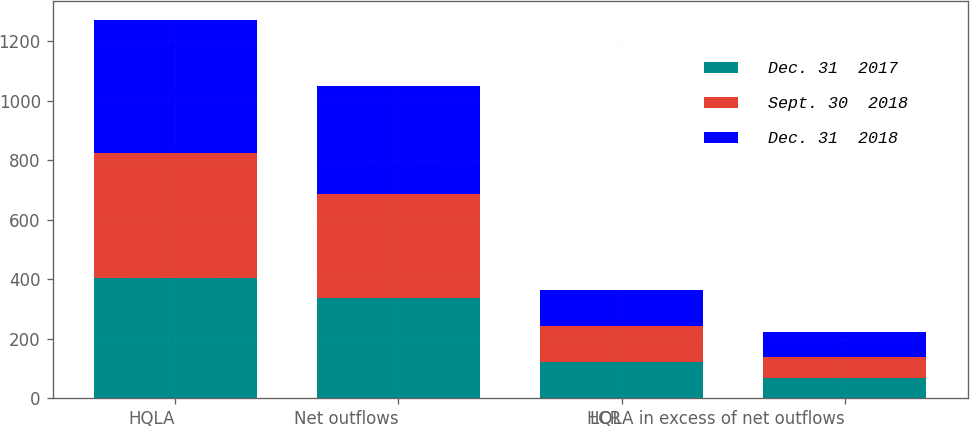Convert chart to OTSL. <chart><loc_0><loc_0><loc_500><loc_500><stacked_bar_chart><ecel><fcel>HQLA<fcel>Net outflows<fcel>LCR<fcel>HQLA in excess of net outflows<nl><fcel>Dec. 31  2017<fcel>403.7<fcel>334.8<fcel>121<fcel>68.9<nl><fcel>Sept. 30  2018<fcel>420.8<fcel>350.8<fcel>120<fcel>70<nl><fcel>Dec. 31  2018<fcel>446.4<fcel>364.3<fcel>123<fcel>82.1<nl></chart> 